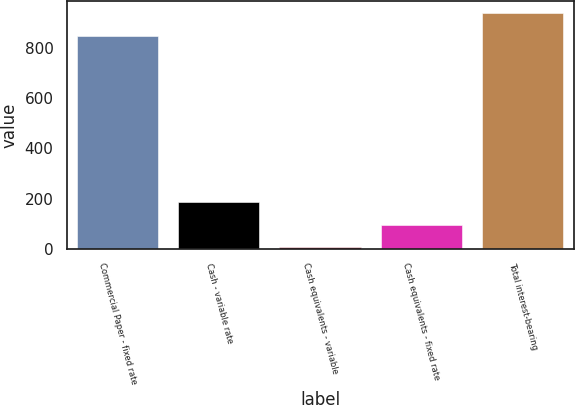Convert chart to OTSL. <chart><loc_0><loc_0><loc_500><loc_500><bar_chart><fcel>Commercial Paper - fixed rate<fcel>Cash - variable rate<fcel>Cash equivalents - variable<fcel>Cash equivalents - fixed rate<fcel>Total interest-bearing<nl><fcel>848.3<fcel>187.2<fcel>6<fcel>96.6<fcel>938.9<nl></chart> 